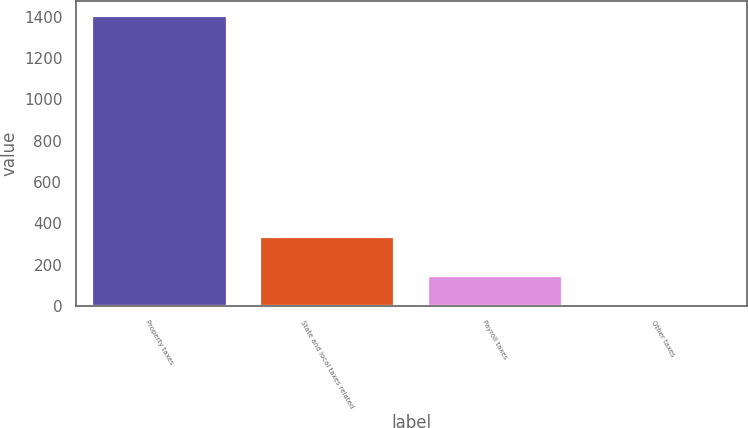<chart> <loc_0><loc_0><loc_500><loc_500><bar_chart><fcel>Property taxes<fcel>State and local taxes related<fcel>Payroll taxes<fcel>Other taxes<nl><fcel>1406<fcel>332<fcel>145.1<fcel>5<nl></chart> 